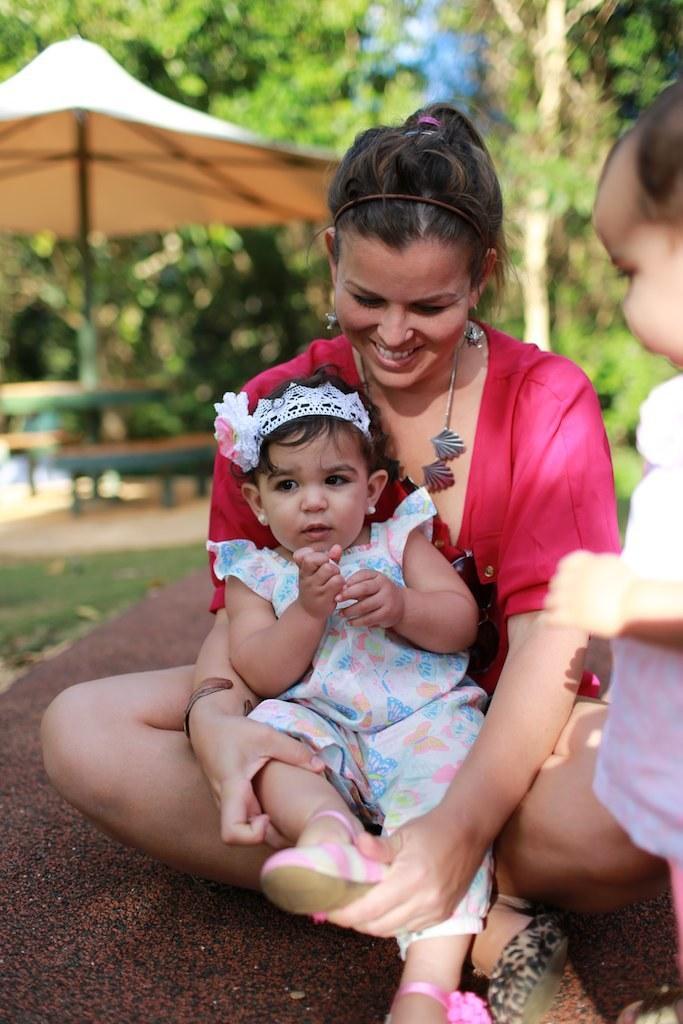Describe this image in one or two sentences. In this picture we can see a baby sitting on a woman. This woman is sitting on the ground. There is a kid standing on the right side. Some grass is visible on the ground. There is a tent, few objects and some trees are visible in the background. Background is blurry. 